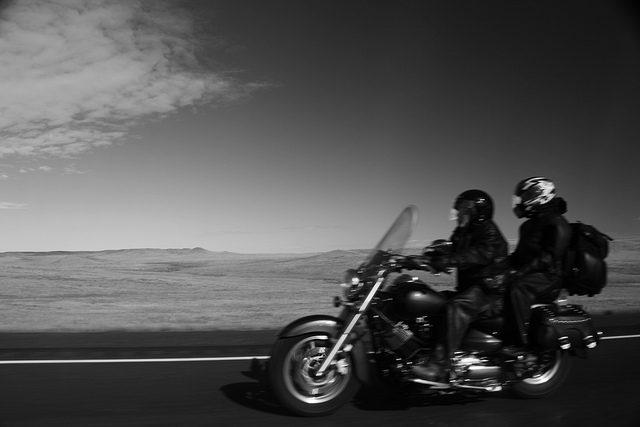Can you describe the environment in which the riders are traveling? The riders are traveling through a vast, open landscape that appears to be a dry grassland or prairie. The horizon stretches far in the background under a wide, mostly clear sky with minimal cloud coverage, providing a sense of isolation and freedom. This setting enhances the feel of an adventurous road trip in remote areas. How does the setting contribute to the overall experience of the riders? The expansive setting contributes significantly to the riders' experience by offering a sense of freedom and escape from urban confines. It accentuates the thrill of motorcycling as an adventurous pursuit, where one can connect with the environment and enjoy the profound peace of wide, open spaces. 